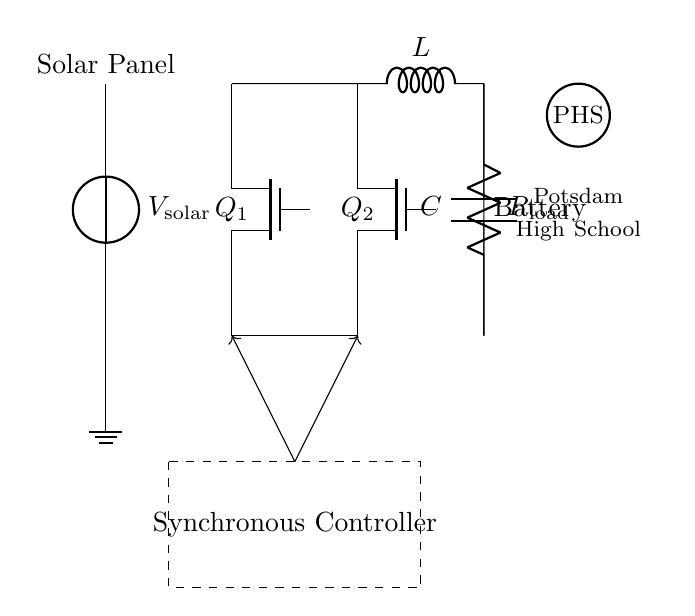What component is used for voltage control in this circuit? The synchronous controller is the component that manages the operation of the MOSFET switches for efficient voltage regulation.
Answer: Synchronous controller What type of MOSFETs are used in this circuit? The circuit shows N-channel MOSFETs, indicated by the labels on the switches, which are typically used for efficiency in this application.
Answer: N-channel How many switches are present in the circuit? There are two switches (Q1 and Q2) in this synchronous rectifier design for controlling current flow.
Answer: Two What is the purpose of the inductor in this circuit? The inductor serves to store energy and smooth the output current, contributing to overall efficiency in charging.
Answer: Energy storage Which component directly manages the current flow to the load? The load resistor is connected directly to the output of the circuit, making it the component that allows current to flow to the load.
Answer: Load resistor What is the significance of using synchronous rectification in solar panel systems? Synchronous rectification improves efficiency by reducing switching losses compared to traditional diodes, maximizing energy harvested from the solar panel.
Answer: Efficiency improvement What is the nature of the voltage source indicated in the circuit? The voltage source represents the solar panel, signifying that it is supplying the voltage needed for the charging circuit operation.
Answer: Solar panel 